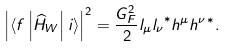<formula> <loc_0><loc_0><loc_500><loc_500>\left | \langle f \left | \widehat { H } _ { W } \right | i \rangle \right | ^ { 2 } = \frac { G _ { F } ^ { 2 } } { 2 } l _ { \mu } { l _ { \nu } } ^ { * } h ^ { \mu } h ^ { \nu \, * } .</formula> 